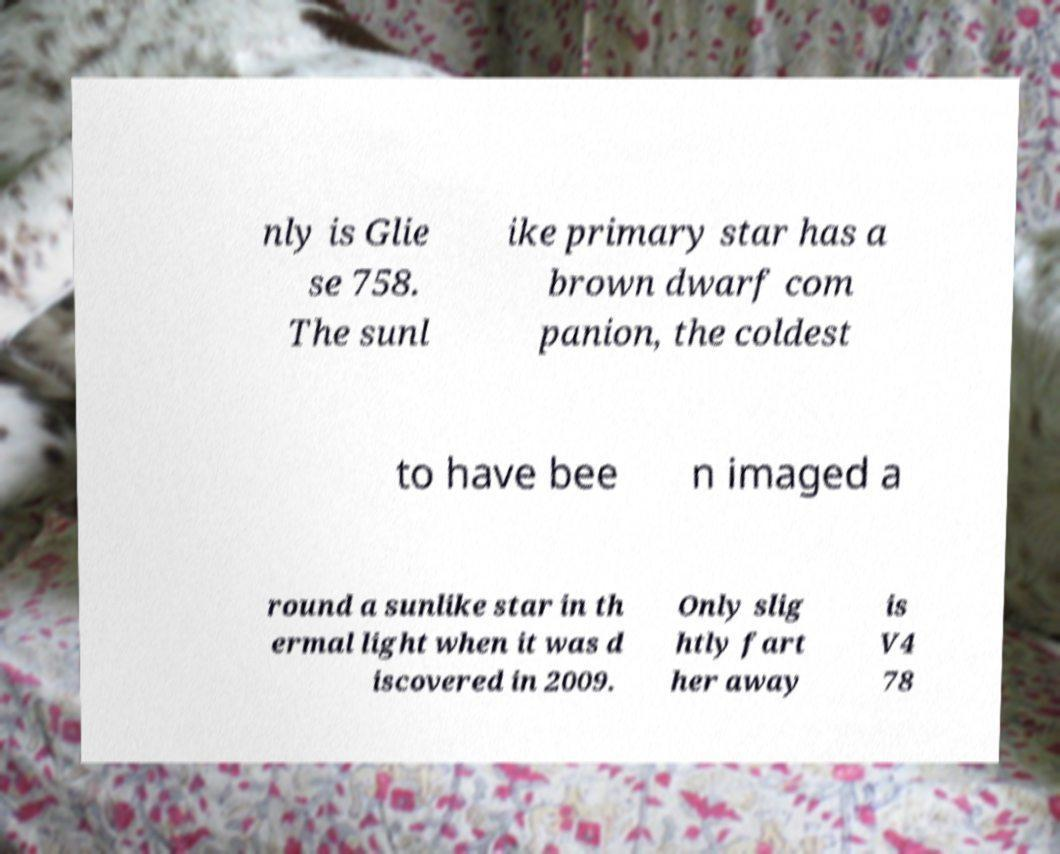I need the written content from this picture converted into text. Can you do that? nly is Glie se 758. The sunl ike primary star has a brown dwarf com panion, the coldest to have bee n imaged a round a sunlike star in th ermal light when it was d iscovered in 2009. Only slig htly fart her away is V4 78 